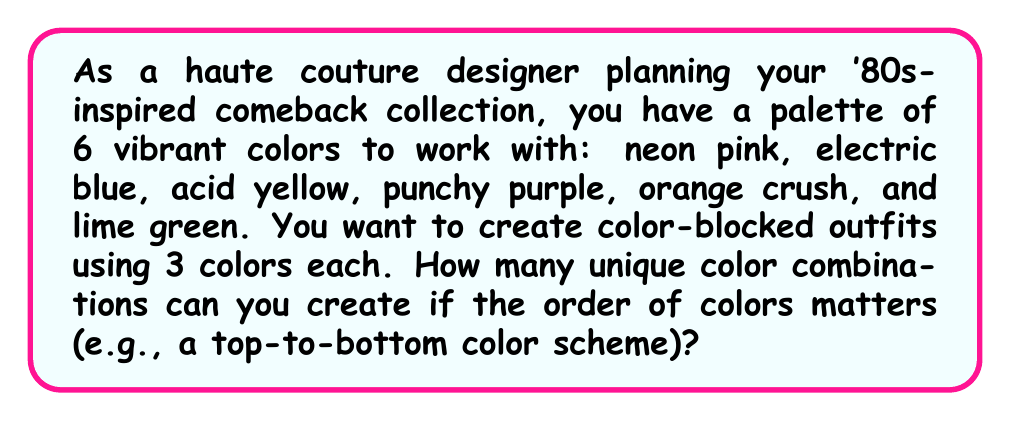Teach me how to tackle this problem. To solve this problem, we need to use the concept of permutations from Group theory. 

1) We are selecting 3 colors out of 6, where the order matters. This is a permutation without repetition.

2) The formula for permutations without repetition is:

   $$P(n,r) = \frac{n!}{(n-r)!}$$

   Where $n$ is the total number of items to choose from, and $r$ is the number of items being chosen.

3) In this case, $n = 6$ (total colors) and $r = 3$ (colors used in each outfit).

4) Plugging these values into our formula:

   $$P(6,3) = \frac{6!}{(6-3)!} = \frac{6!}{3!}$$

5) Expanding this:
   
   $$\frac{6 \times 5 \times 4 \times 3!}{3!}$$

6) The $3!$ cancels out in the numerator and denominator:

   $$6 \times 5 \times 4 = 120$$

Therefore, you can create 120 unique color combinations for your '80s-inspired outfits.
Answer: 120 unique color combinations 